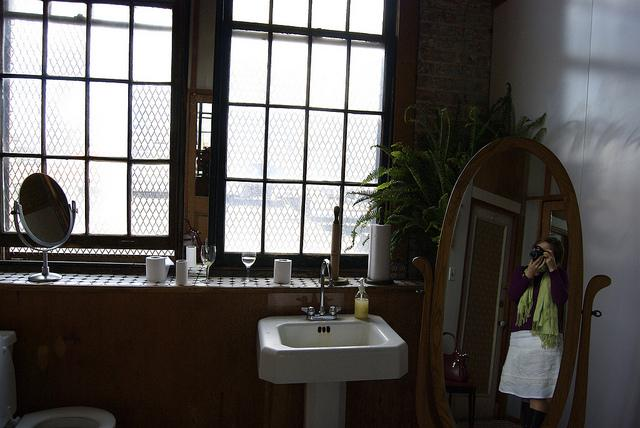Which feature of the camera poses harm to the person taking a photograph of a mirror? flash 